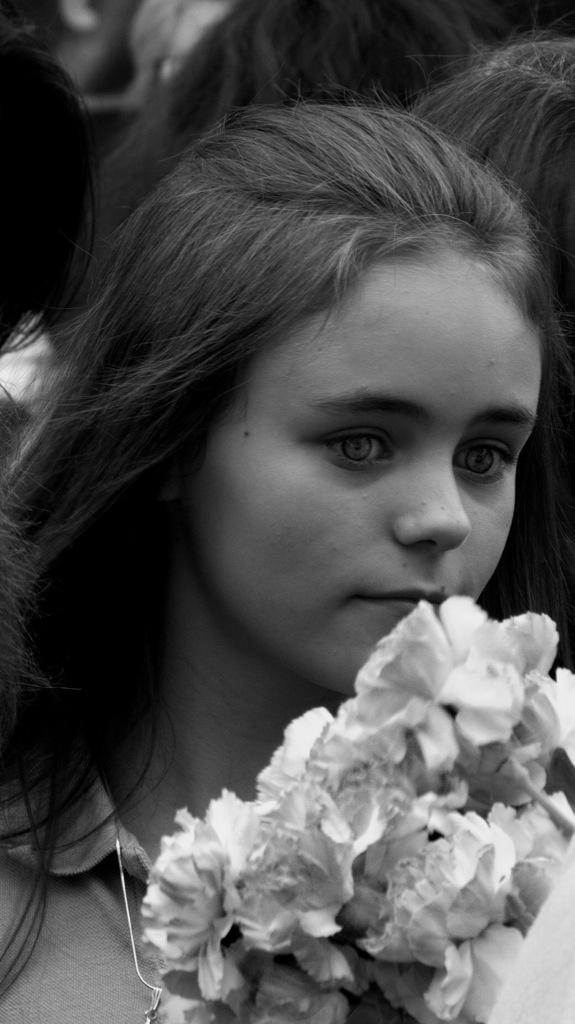Who is the main subject in the image? There is a girl in the image. What is the color scheme of the image? The image is black and white. What is in front of the girl in the image? There is a bouquet in front of the girl. What type of screw can be seen holding the bouquet together in the image? There is no screw present in the image; the bouquet is not held together by any visible screws. 